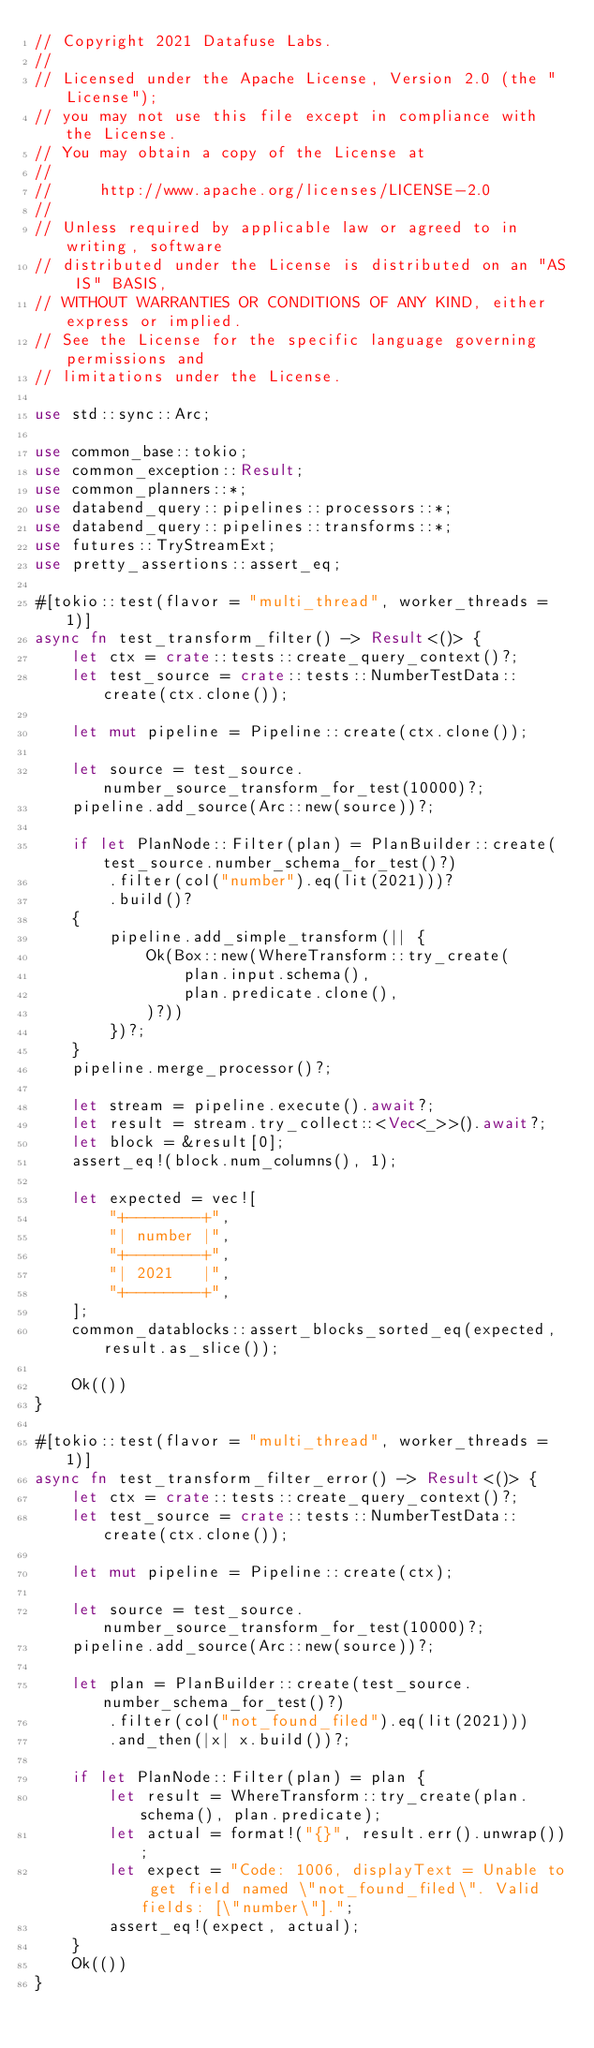Convert code to text. <code><loc_0><loc_0><loc_500><loc_500><_Rust_>// Copyright 2021 Datafuse Labs.
//
// Licensed under the Apache License, Version 2.0 (the "License");
// you may not use this file except in compliance with the License.
// You may obtain a copy of the License at
//
//     http://www.apache.org/licenses/LICENSE-2.0
//
// Unless required by applicable law or agreed to in writing, software
// distributed under the License is distributed on an "AS IS" BASIS,
// WITHOUT WARRANTIES OR CONDITIONS OF ANY KIND, either express or implied.
// See the License for the specific language governing permissions and
// limitations under the License.

use std::sync::Arc;

use common_base::tokio;
use common_exception::Result;
use common_planners::*;
use databend_query::pipelines::processors::*;
use databend_query::pipelines::transforms::*;
use futures::TryStreamExt;
use pretty_assertions::assert_eq;

#[tokio::test(flavor = "multi_thread", worker_threads = 1)]
async fn test_transform_filter() -> Result<()> {
    let ctx = crate::tests::create_query_context()?;
    let test_source = crate::tests::NumberTestData::create(ctx.clone());

    let mut pipeline = Pipeline::create(ctx.clone());

    let source = test_source.number_source_transform_for_test(10000)?;
    pipeline.add_source(Arc::new(source))?;

    if let PlanNode::Filter(plan) = PlanBuilder::create(test_source.number_schema_for_test()?)
        .filter(col("number").eq(lit(2021)))?
        .build()?
    {
        pipeline.add_simple_transform(|| {
            Ok(Box::new(WhereTransform::try_create(
                plan.input.schema(),
                plan.predicate.clone(),
            )?))
        })?;
    }
    pipeline.merge_processor()?;

    let stream = pipeline.execute().await?;
    let result = stream.try_collect::<Vec<_>>().await?;
    let block = &result[0];
    assert_eq!(block.num_columns(), 1);

    let expected = vec![
        "+--------+",
        "| number |",
        "+--------+",
        "| 2021   |",
        "+--------+",
    ];
    common_datablocks::assert_blocks_sorted_eq(expected, result.as_slice());

    Ok(())
}

#[tokio::test(flavor = "multi_thread", worker_threads = 1)]
async fn test_transform_filter_error() -> Result<()> {
    let ctx = crate::tests::create_query_context()?;
    let test_source = crate::tests::NumberTestData::create(ctx.clone());

    let mut pipeline = Pipeline::create(ctx);

    let source = test_source.number_source_transform_for_test(10000)?;
    pipeline.add_source(Arc::new(source))?;

    let plan = PlanBuilder::create(test_source.number_schema_for_test()?)
        .filter(col("not_found_filed").eq(lit(2021)))
        .and_then(|x| x.build())?;

    if let PlanNode::Filter(plan) = plan {
        let result = WhereTransform::try_create(plan.schema(), plan.predicate);
        let actual = format!("{}", result.err().unwrap());
        let expect = "Code: 1006, displayText = Unable to get field named \"not_found_filed\". Valid fields: [\"number\"].";
        assert_eq!(expect, actual);
    }
    Ok(())
}
</code> 